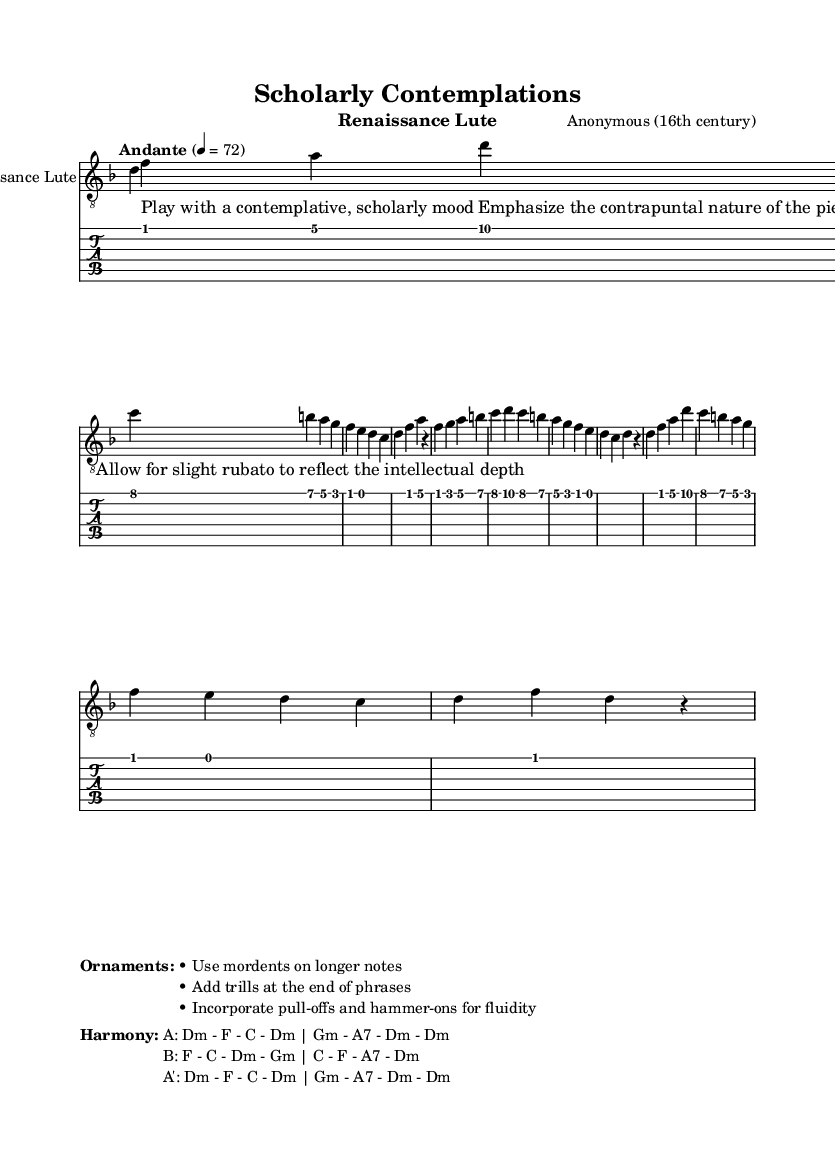What is the key signature of this music? The key signature is indicated at the beginning of the musical staff. In this case, the key signature shows one flat, which corresponds to D minor.
Answer: D minor What is the time signature of this music? The time signature is displayed at the beginning of the score, following the key signature. Here, it is shown as 4/4, meaning there are four beats in each measure.
Answer: 4/4 What is the tempo marking for this piece? The tempo marking is displayed at the beginning and indicates the speed of the piece. Here, it states "Andante" with a metronome marking of 72, suggesting a moderate walking pace.
Answer: Andante, 72 How many sections are there in the music, and what are they labeled? By observing the structure of the piece, we can see there are three main sections labeled as Section A, Section B, and Section A', indicating a return to the initial thematic material after the contrast.
Answer: Three sections: A, B, A' What is the main mood that is suggested for performing this piece? The performance notes provided as lyrics indicate the intended mood, which is described as "Play with a contemplative, scholarly mood," guiding the performer to convey a specific emotional character.
Answer: Contemplative, scholarly mood What are the chord progressions used in Section A? To determine the chord progressions, we look at the harmony provided in the markup. The chords for Section A are specified as: D minor, F, C, D minor; G minor, A7, D minor.
Answer: D minor - F - C - D minor; G minor - A7 - D minor What kind of flourishes and techniques are suggested for performance? The appropriate techniques are outlined under "Ornaments" in the markup section. They include suggestions like using mordents, adding trills, and incorporating pull-offs and hammer-ons to enhance the performance.
Answer: Mordents, trills, pull-offs, hammer-ons 